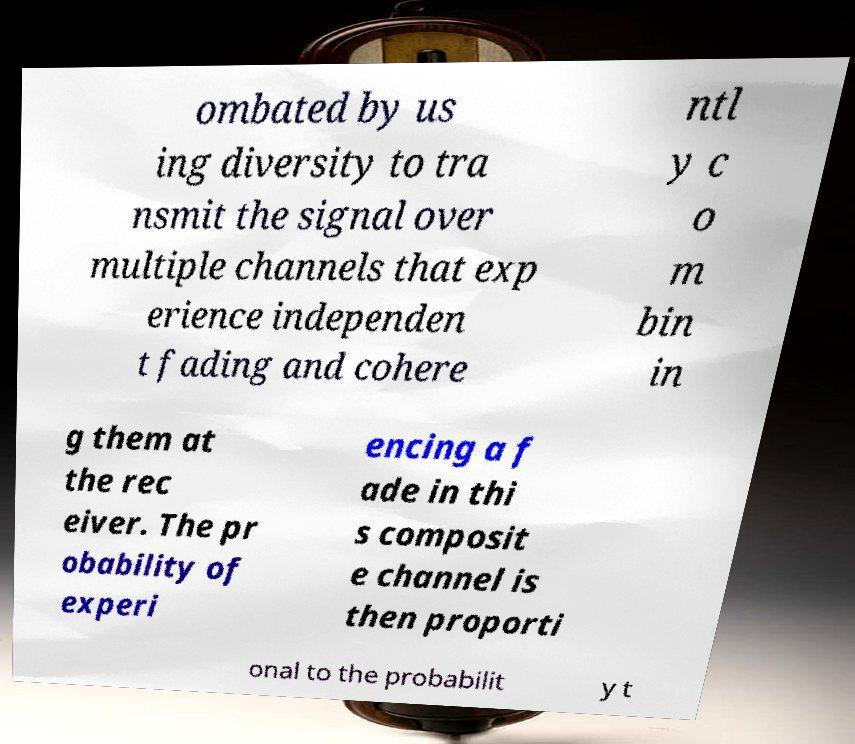I need the written content from this picture converted into text. Can you do that? ombated by us ing diversity to tra nsmit the signal over multiple channels that exp erience independen t fading and cohere ntl y c o m bin in g them at the rec eiver. The pr obability of experi encing a f ade in thi s composit e channel is then proporti onal to the probabilit y t 